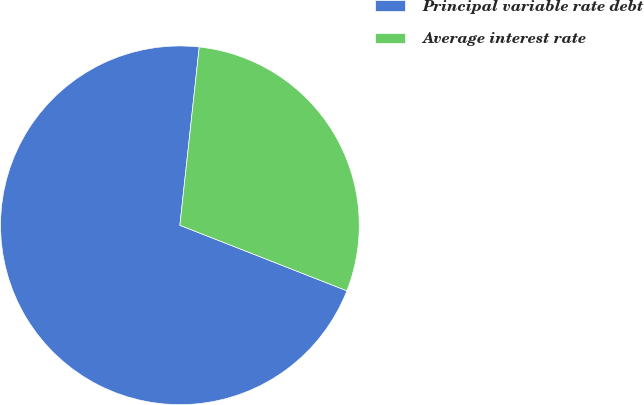Convert chart. <chart><loc_0><loc_0><loc_500><loc_500><pie_chart><fcel>Principal variable rate debt<fcel>Average interest rate<nl><fcel>70.77%<fcel>29.23%<nl></chart> 